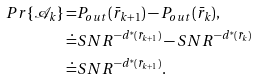<formula> <loc_0><loc_0><loc_500><loc_500>P r \{ \mathcal { A } _ { k } \} = & P _ { o u t } ( \bar { r } _ { k + 1 } ) - P _ { o u t } ( \bar { r } _ { k } ) , \\ \doteq & S N R ^ { - d ^ { * } ( \bar { r } _ { k + 1 } ) } - S N R ^ { - d ^ { * } ( \bar { r } _ { k } ) } \\ \doteq & S N R ^ { - d ^ { * } ( \bar { r } _ { k + 1 } ) } .</formula> 